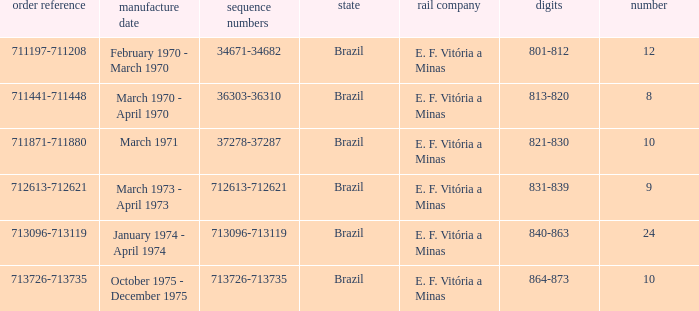What are the numbers for the order number 713096-713119? 840-863. 